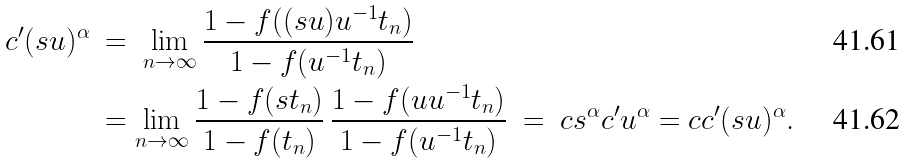<formula> <loc_0><loc_0><loc_500><loc_500>c ^ { \prime } ( s u ) ^ { \alpha } \ & = \ \lim _ { n \to \infty } \frac { 1 - f ( ( s u ) u ^ { - 1 } t _ { n } ) } { 1 - f ( u ^ { - 1 } t _ { n } ) } \\ & = \lim _ { n \to \infty } \frac { 1 - f ( s t _ { n } ) } { 1 - f ( t _ { n } ) } \, \frac { 1 - f ( u u ^ { - 1 } t _ { n } ) } { 1 - f ( u ^ { - 1 } t _ { n } ) } \ = \ c s ^ { \alpha } c ^ { \prime } u ^ { \alpha } = c c ^ { \prime } ( s u ) ^ { \alpha } .</formula> 